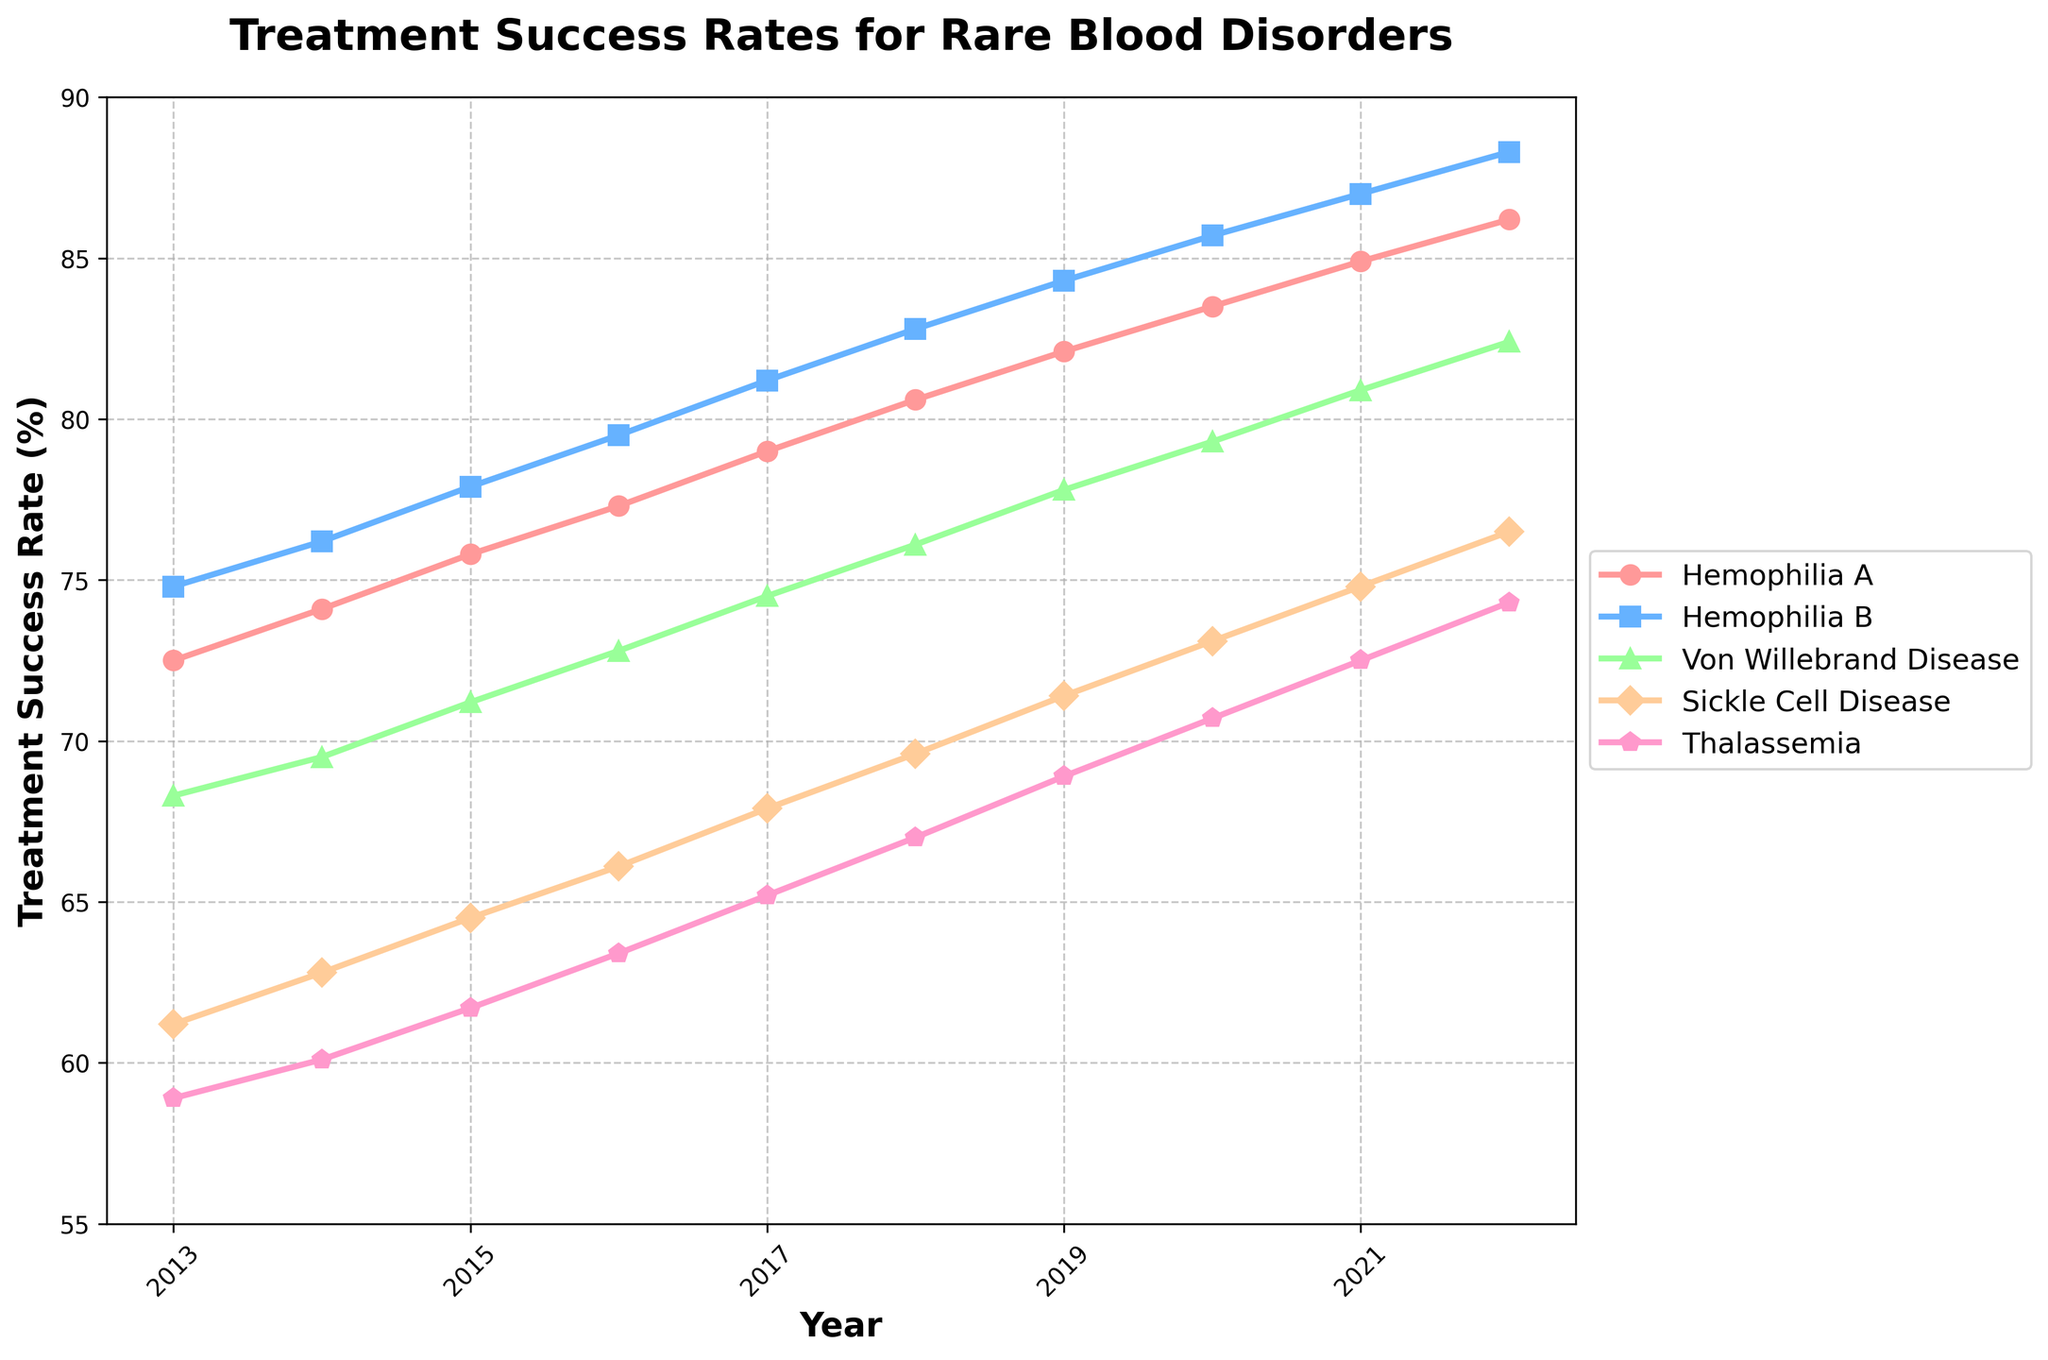Which disorder shows the highest treatment success rate in 2022? Look at the data points for 2022. The highest value is 88.3% for Hemophilia B.
Answer: Hemophilia B What's the difference in treatment success rates between Hemophilia A and Thalassemia in 2015? Locate the data points for both Hemophilia A and Thalassemia in 2015. Hemophilia A has 75.8% and Thalassemia has 61.7%. Subtract 61.7 from 75.8.
Answer: 14.1 Which two disorders have the most similar treatment success rates in 2019? Compare the values for all disorders in 2019. Hemophilia B has 84.3% and Von Willebrand Disease has 77.8%. These two are the closest.
Answer: Hemophilia B and Von Willebrand Disease What was the average treatment success rate for Sickle Cell Disease from 2013 to 2016? Add the percentages for Sickle Cell Disease from 2013 to 2016: 61.2% + 62.8% + 64.5% + 66.1% = 254.6%. Then divide by 4 (the number of years).
Answer: 63.65 Was the improvement in treatment success rate for Von Willebrand Disease greater from 2013 to 2014 or from 2021 to 2022? From 2013 to 2014, it went from 68.3% to 69.5% (an increase of 1.2%). From 2021 to 2022, it went from 80.9% to 82.4% (an increase of 1.5%).
Answer: 2021 to 2022 Between which two consecutive years did Sickle Cell Disease see the greatest improvement in treatment success rates? Compare the year-over-year changes for Sickle Cell Disease: 61.2→62.8, 62.8→64.5, 64.5→66.1, 66.1→67.9, etc. The greatest change is 67.9 to 69.6 (1.7%).
Answer: 2017 to 2018 What is the trend in treatment success rates for Thalassemia over the decade? Compare the values for Thalassemia from 2013 (58.9%) to 2022 (74.3%). The success rate shows a consistent upward trend each year.
Answer: Increasing Between Hemophilia A and Hemophilia B, which disorder had a consistently higher treatment success rate throughout the decade? Compare the values year-by-year for Hemophilia A and Hemophilia B. Hemophilia B is consistently higher each year.
Answer: Hemophilia B In which year did Von Willebrand Disease first surpass 75% in treatment success rates? Locate the data points for Von Willebrand Disease across the years. It first surpasses 75% in 2018 with 76.1%.
Answer: 2018 By how much did the treatment success rate for Thalassemia improve from 2013 to 2022? Subtract the value in 2013 (58.9%) from the value in 2022 (74.3%).
Answer: 15.4 